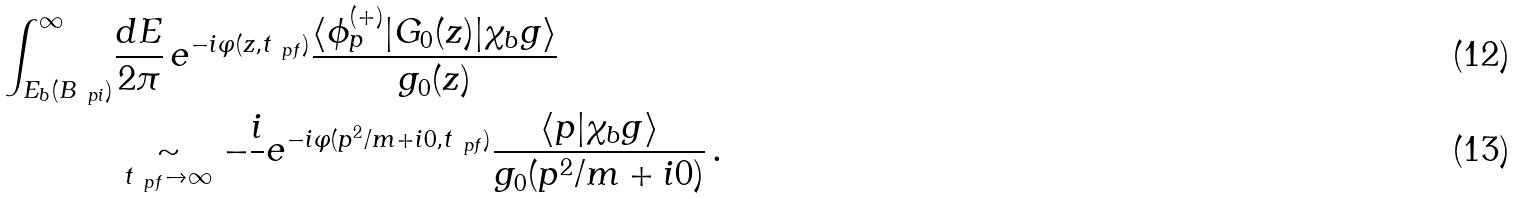Convert formula to latex. <formula><loc_0><loc_0><loc_500><loc_500>\int _ { E _ { b } ( B _ { \ p { i } } ) } ^ { \infty } & \frac { d E } { 2 \pi } \, e ^ { - i \varphi ( z , t _ { \ p { f } } ) } \frac { \langle \phi _ { p } ^ { ( + ) } | G _ { 0 } ( z ) | \chi _ { b } g \rangle } { g _ { 0 } ( z ) } \\ & \underset { t _ { \ p { f } } \to \infty } { \sim } - \frac { i } { } e ^ { - i \varphi ( p ^ { 2 } / m + i 0 , t _ { \ p { f } } ) } \frac { \langle p | \chi _ { b } g \rangle } { g _ { 0 } ( p ^ { 2 } / m + i 0 ) } \, .</formula> 